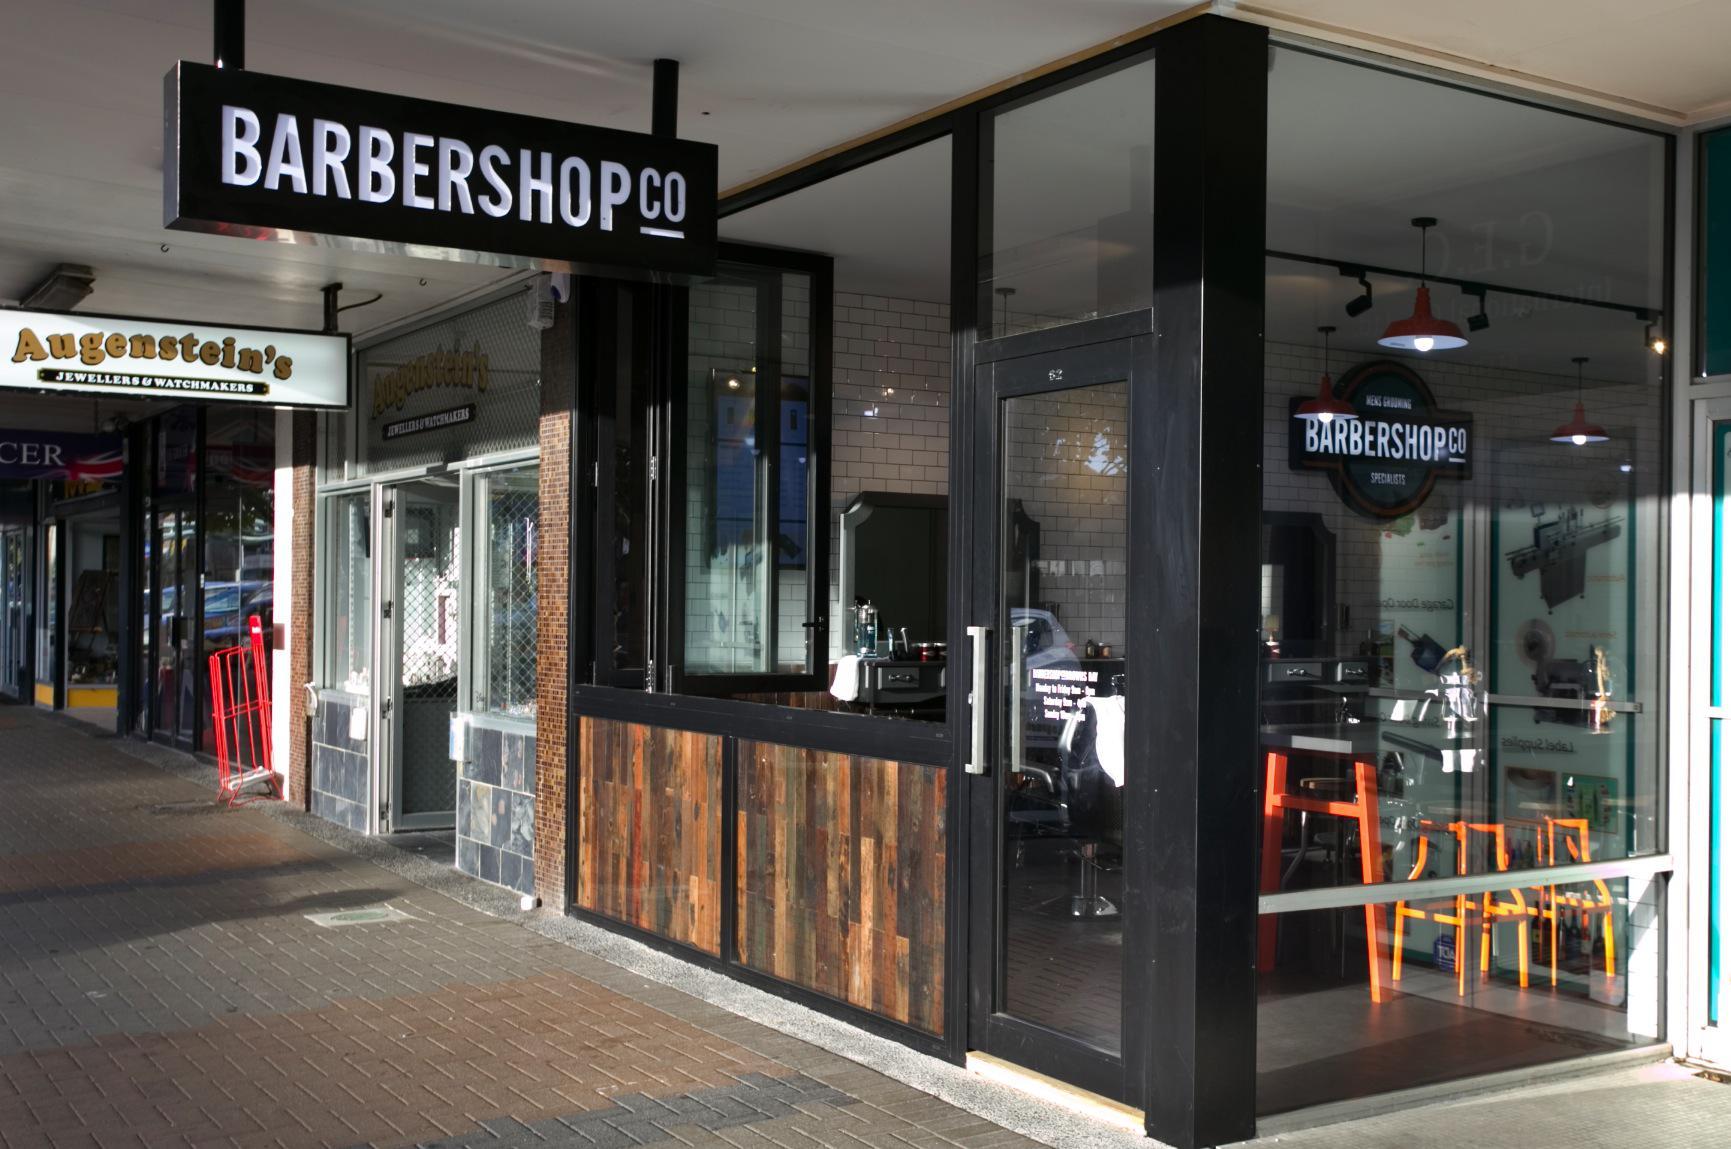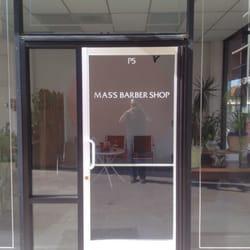The first image is the image on the left, the second image is the image on the right. For the images shown, is this caption "There is at least one barber pole in the image on the left." true? Answer yes or no. No. The first image is the image on the left, the second image is the image on the right. Analyze the images presented: Is the assertion "A barber shop has a red brick exterior with a row of black-rimmed windows parallel to the sidewalk." valid? Answer yes or no. No. 